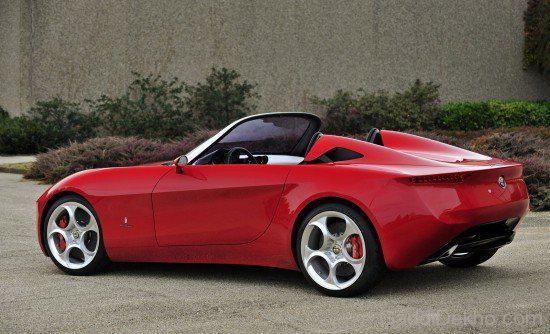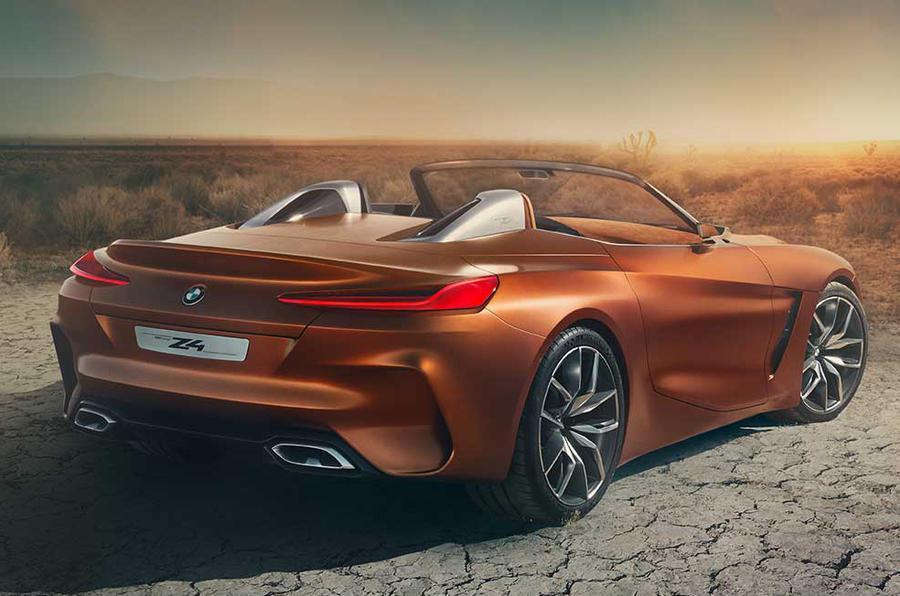The first image is the image on the left, the second image is the image on the right. Assess this claim about the two images: "One image has an orange BMW facing the right.". Correct or not? Answer yes or no. Yes. 